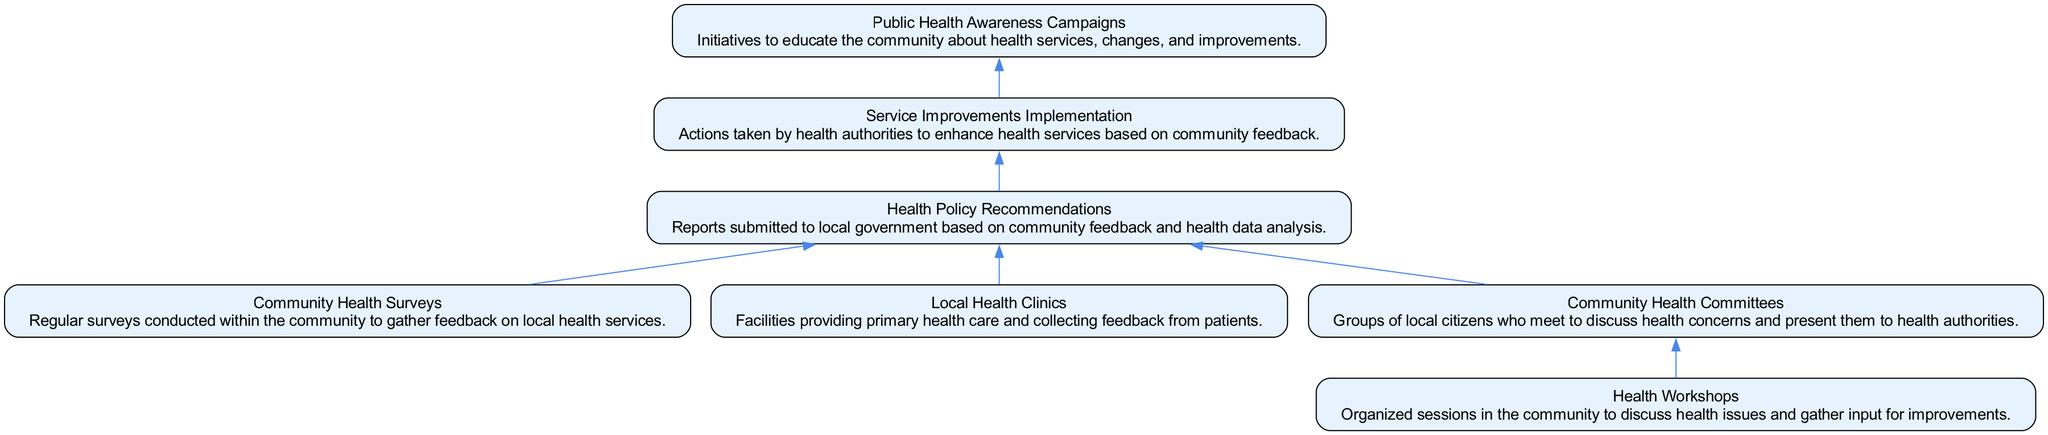What are the initial inputs in the feedback loop? The diagram shows that "Community Health Surveys," "Local Health Clinics," and "Health Workshops" are the initial nodes leading to further outputs. These nodes gather community input.
Answer: Community Health Surveys, Local Health Clinics, Health Workshops How many nodes are present in the diagram? By counting each element listed in the data for the diagram, we find that there are a total of seven nodes present.
Answer: Seven What is the output after "Health Policy Recommendations"? According to the diagram, the next step after "Health Policy Recommendations" is "Service Improvements Implementation." This indicates the action taken based on the recommendations made.
Answer: Service Improvements Implementation Which node directly follows "Community Health Committees"? The flow progression shows that "Community Health Committees" leads to "Health Policy Recommendations," which follows directly after the committee discussions.
Answer: Health Policy Recommendations What are the last two nodes in the feedback loop? Tracing the flow from the start to the end, the last two nodes are "Service Improvements Implementation" and "Public Health Awareness Campaigns," indicating the final actions and responses to feedback.
Answer: Service Improvements Implementation, Public Health Awareness Campaigns What type of information do "Health Workshops" contribute to the loop? The diagram indicates that "Health Workshops" serve to gather community input, which is then discussed further in "Community Health Committees."
Answer: Community input What relationship do "Local Health Clinics" and "Community Health Surveys" share in the diagram? Both "Local Health Clinics" and "Community Health Surveys" provide feedback that informs the "Health Policy Recommendations," indicating they have a parallel relationship in feeding information into the policy-making process.
Answer: Feedback to Health Policy Recommendations Which node represents educational initiatives in the community? The diagram clearly shows that "Public Health Awareness Campaigns" are designed for community education about health services and enhancements.
Answer: Public Health Awareness Campaigns 